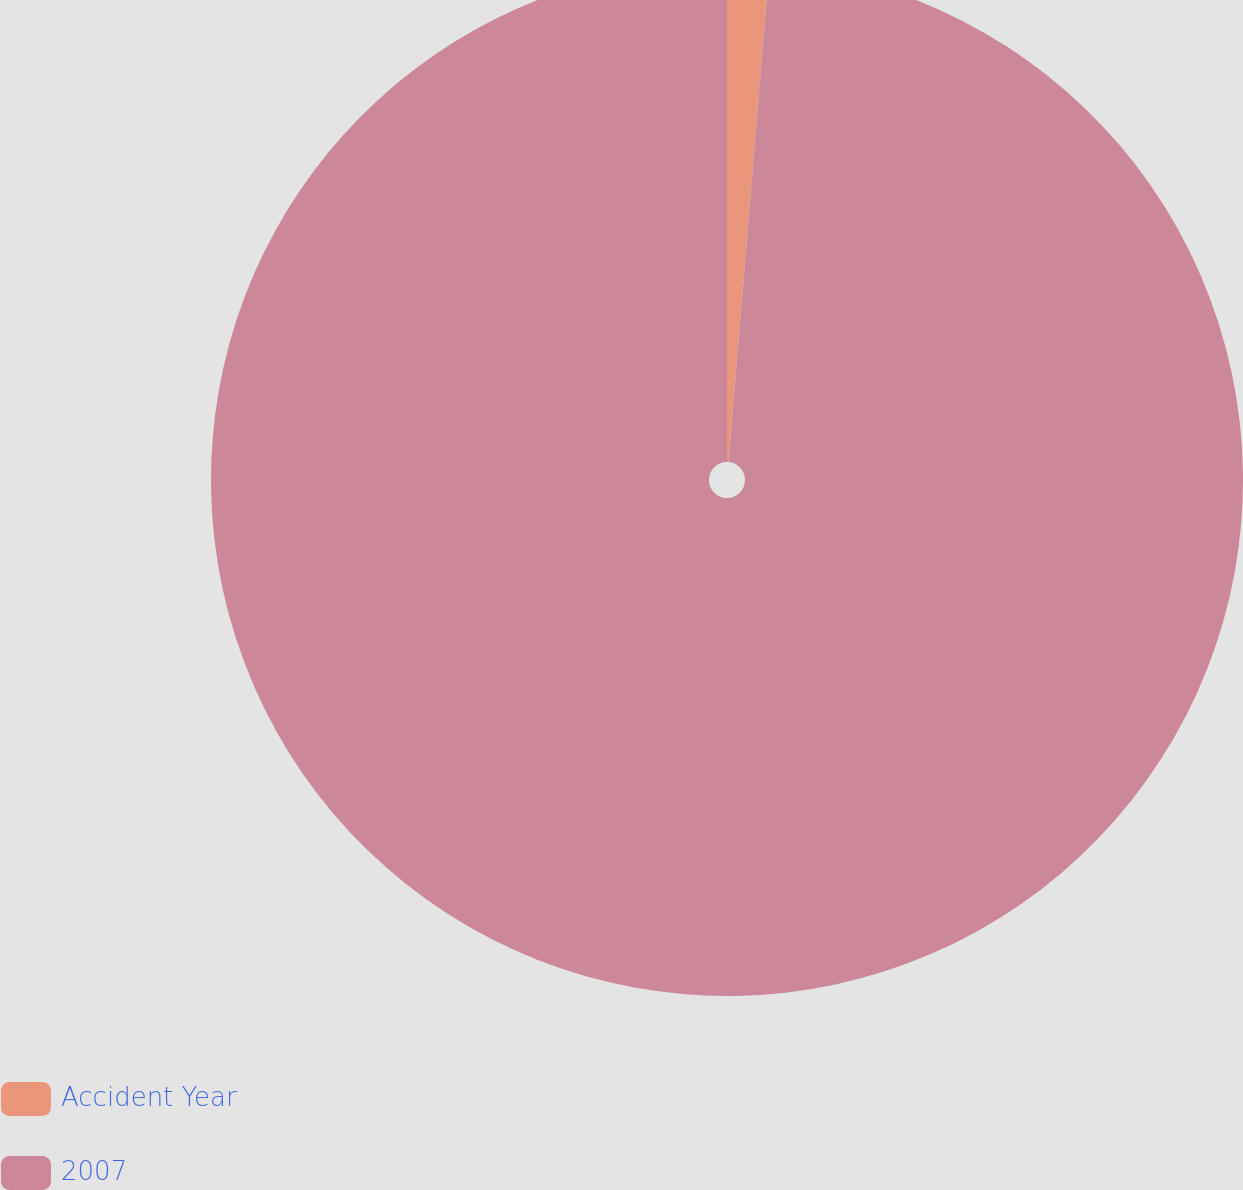Convert chart to OTSL. <chart><loc_0><loc_0><loc_500><loc_500><pie_chart><fcel>Accident Year<fcel>2007<nl><fcel>1.31%<fcel>98.69%<nl></chart> 